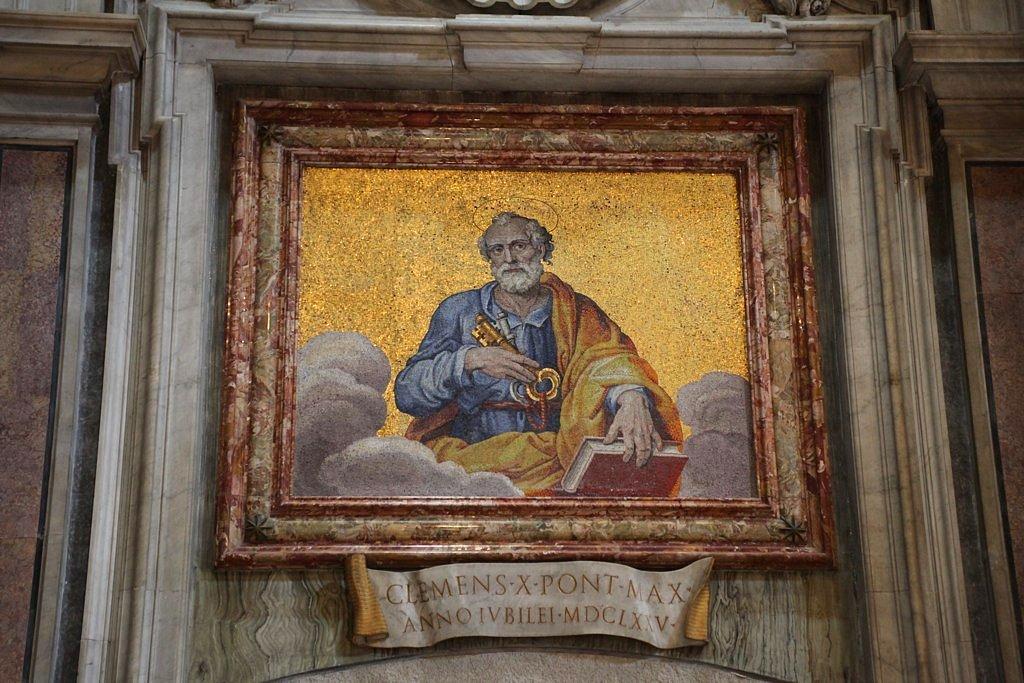Who is this?
Keep it short and to the point. Clemens x. 